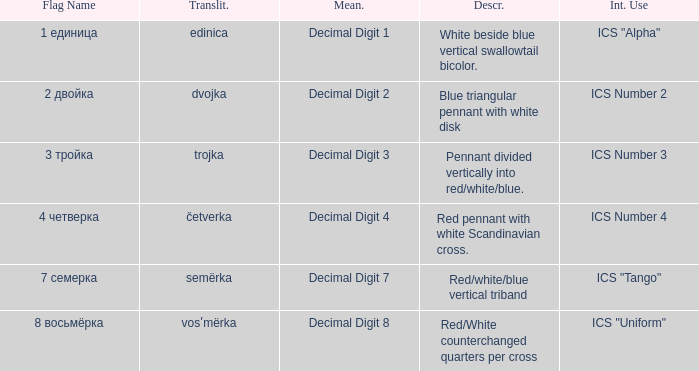What are the meanings of the flag whose name transliterates to semërka? Decimal Digit 7. 